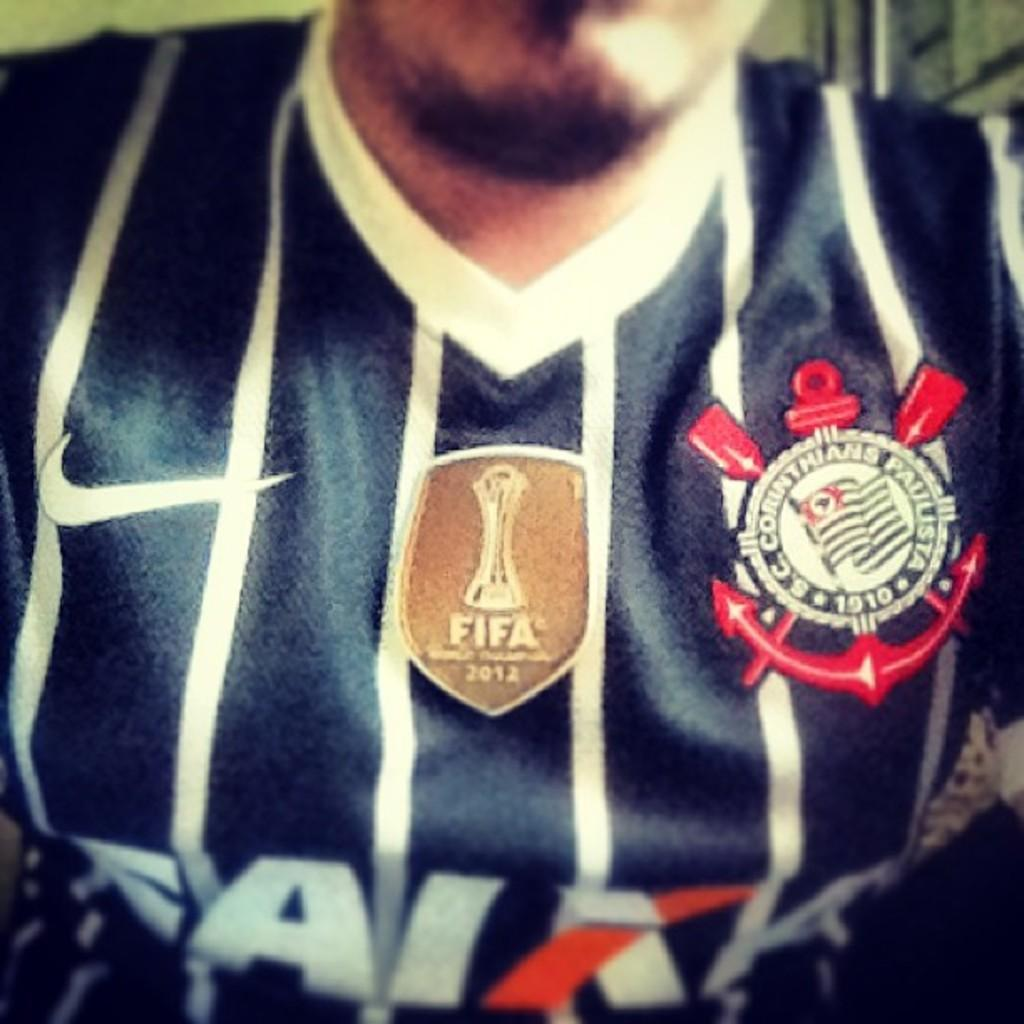<image>
Offer a succinct explanation of the picture presented. a Fifa emblem that is on the jersey of a person 